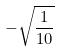<formula> <loc_0><loc_0><loc_500><loc_500>- \sqrt { \frac { 1 } { 1 0 } }</formula> 